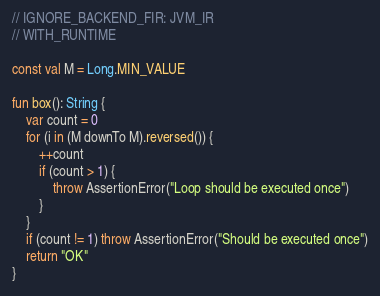<code> <loc_0><loc_0><loc_500><loc_500><_Kotlin_>// IGNORE_BACKEND_FIR: JVM_IR
// WITH_RUNTIME

const val M = Long.MIN_VALUE

fun box(): String {
    var count = 0
    for (i in (M downTo M).reversed()) {
        ++count
        if (count > 1) {
            throw AssertionError("Loop should be executed once")
        }
    }
    if (count != 1) throw AssertionError("Should be executed once")
    return "OK"
}</code> 